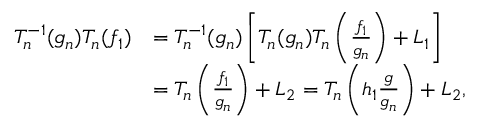<formula> <loc_0><loc_0><loc_500><loc_500>\begin{array} { r l } { T _ { n } ^ { - 1 } ( g _ { n } ) T _ { n } ( f _ { 1 } ) } & { = T _ { n } ^ { - 1 } ( g _ { n } ) \left [ T _ { n } ( g _ { n } ) T _ { n } \left ( \frac { f _ { 1 } } { g _ { n } } \right ) + L _ { 1 } \right ] } \\ & { = T _ { n } \left ( \frac { f _ { 1 } } { g _ { n } } \right ) + L _ { 2 } = T _ { n } \left ( h _ { 1 } \frac { g } { g _ { n } } \right ) + L _ { 2 } , } \end{array}</formula> 